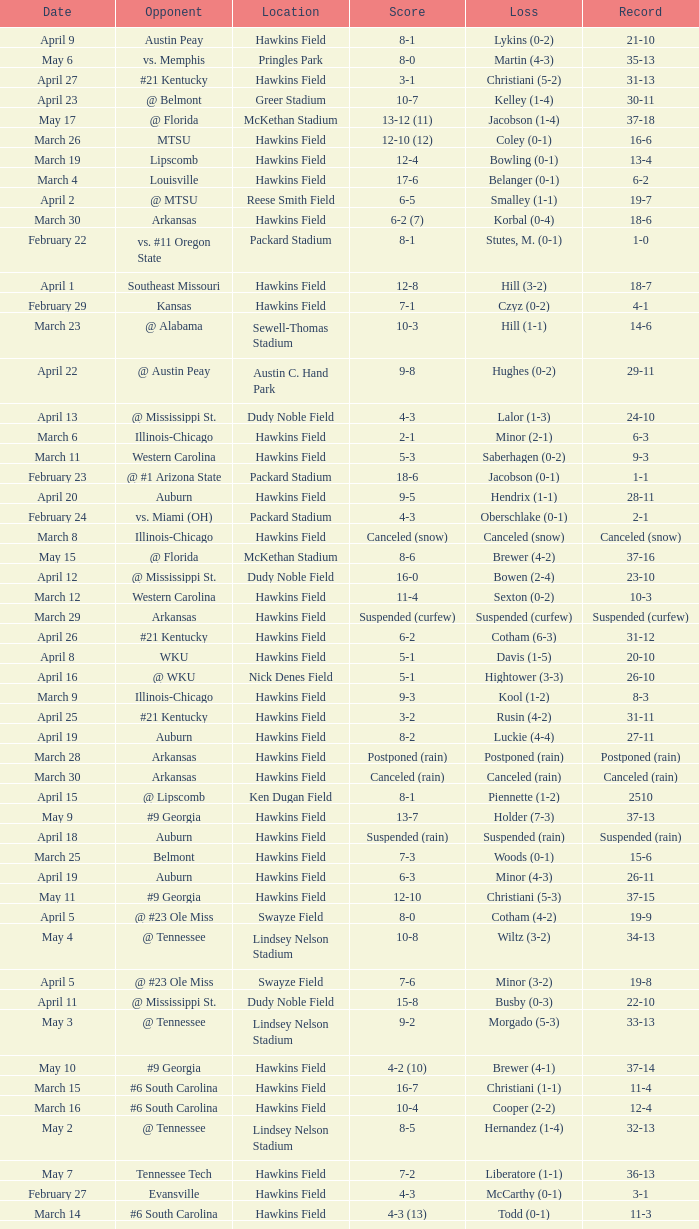What was the location of the game when the record was 2-1? Packard Stadium. 